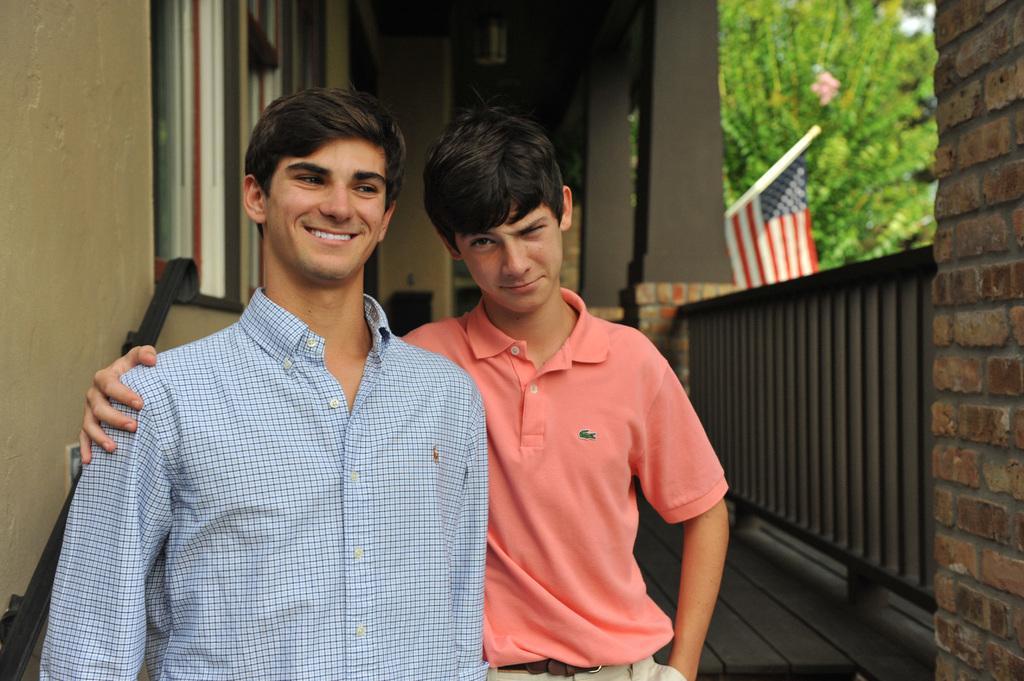In one or two sentences, can you explain what this image depicts? In the image to the left side there is a man with checks shirt and beside him there is a boy with pink t-shirt both are standing. Behind them there are windows to the wall. And to the right corner there is a brick pillar. And beside that there is a railing and also there are two pillars. And to the right top of the image there are trees and flag. 